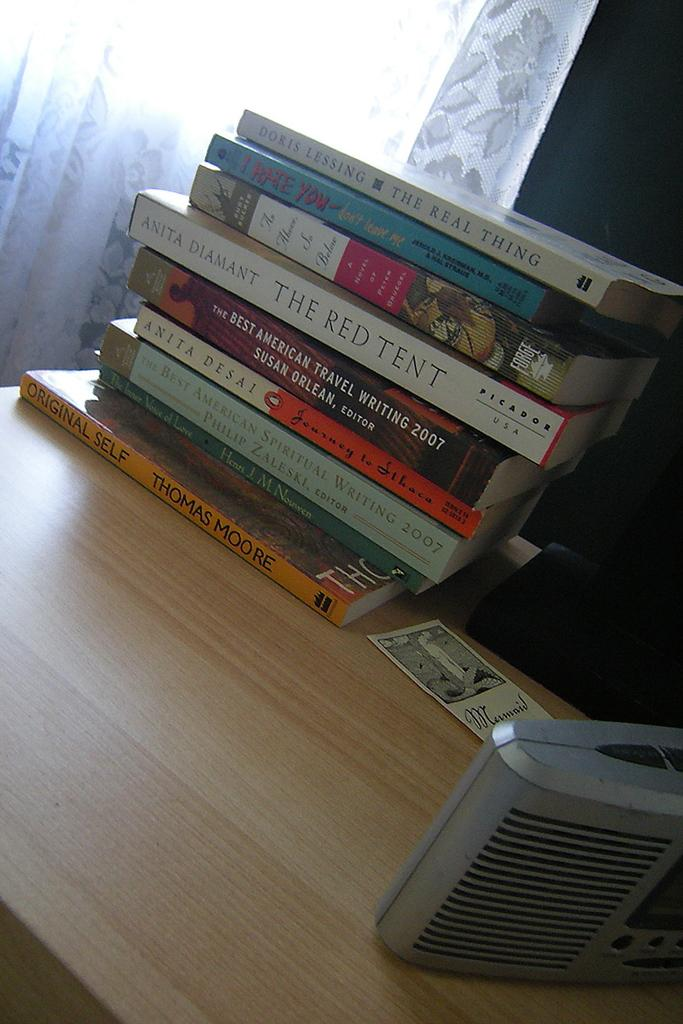Provide a one-sentence caption for the provided image. A stack of paperback books sits on a desk, the top one being The Real Thing. 